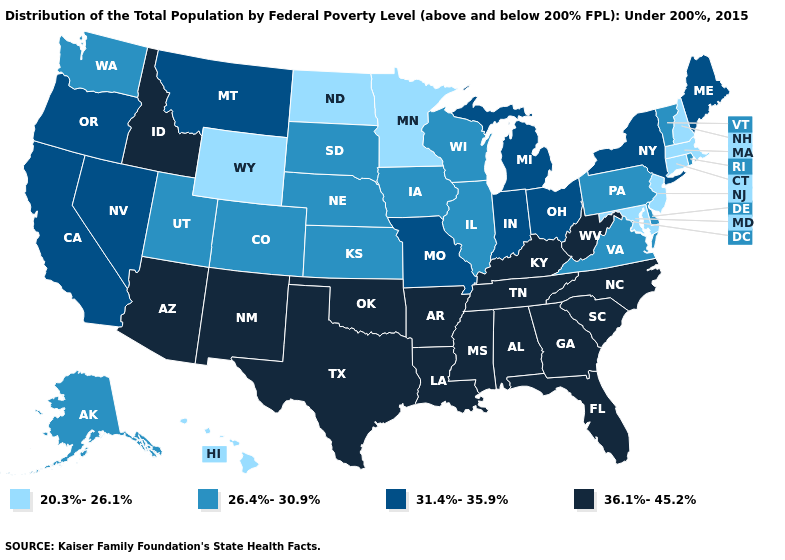Which states have the highest value in the USA?
Be succinct. Alabama, Arizona, Arkansas, Florida, Georgia, Idaho, Kentucky, Louisiana, Mississippi, New Mexico, North Carolina, Oklahoma, South Carolina, Tennessee, Texas, West Virginia. What is the value of Delaware?
Quick response, please. 26.4%-30.9%. Does Utah have the lowest value in the USA?
Concise answer only. No. Name the states that have a value in the range 31.4%-35.9%?
Write a very short answer. California, Indiana, Maine, Michigan, Missouri, Montana, Nevada, New York, Ohio, Oregon. How many symbols are there in the legend?
Quick response, please. 4. Does Wisconsin have the same value as Nebraska?
Write a very short answer. Yes. Which states have the lowest value in the USA?
Short answer required. Connecticut, Hawaii, Maryland, Massachusetts, Minnesota, New Hampshire, New Jersey, North Dakota, Wyoming. Among the states that border Oregon , which have the highest value?
Short answer required. Idaho. What is the lowest value in the USA?
Keep it brief. 20.3%-26.1%. How many symbols are there in the legend?
Be succinct. 4. Does Nevada have the highest value in the USA?
Short answer required. No. Name the states that have a value in the range 31.4%-35.9%?
Give a very brief answer. California, Indiana, Maine, Michigan, Missouri, Montana, Nevada, New York, Ohio, Oregon. Does New Jersey have the lowest value in the Northeast?
Short answer required. Yes. Name the states that have a value in the range 26.4%-30.9%?
Give a very brief answer. Alaska, Colorado, Delaware, Illinois, Iowa, Kansas, Nebraska, Pennsylvania, Rhode Island, South Dakota, Utah, Vermont, Virginia, Washington, Wisconsin. Does New Jersey have the lowest value in the Northeast?
Answer briefly. Yes. 